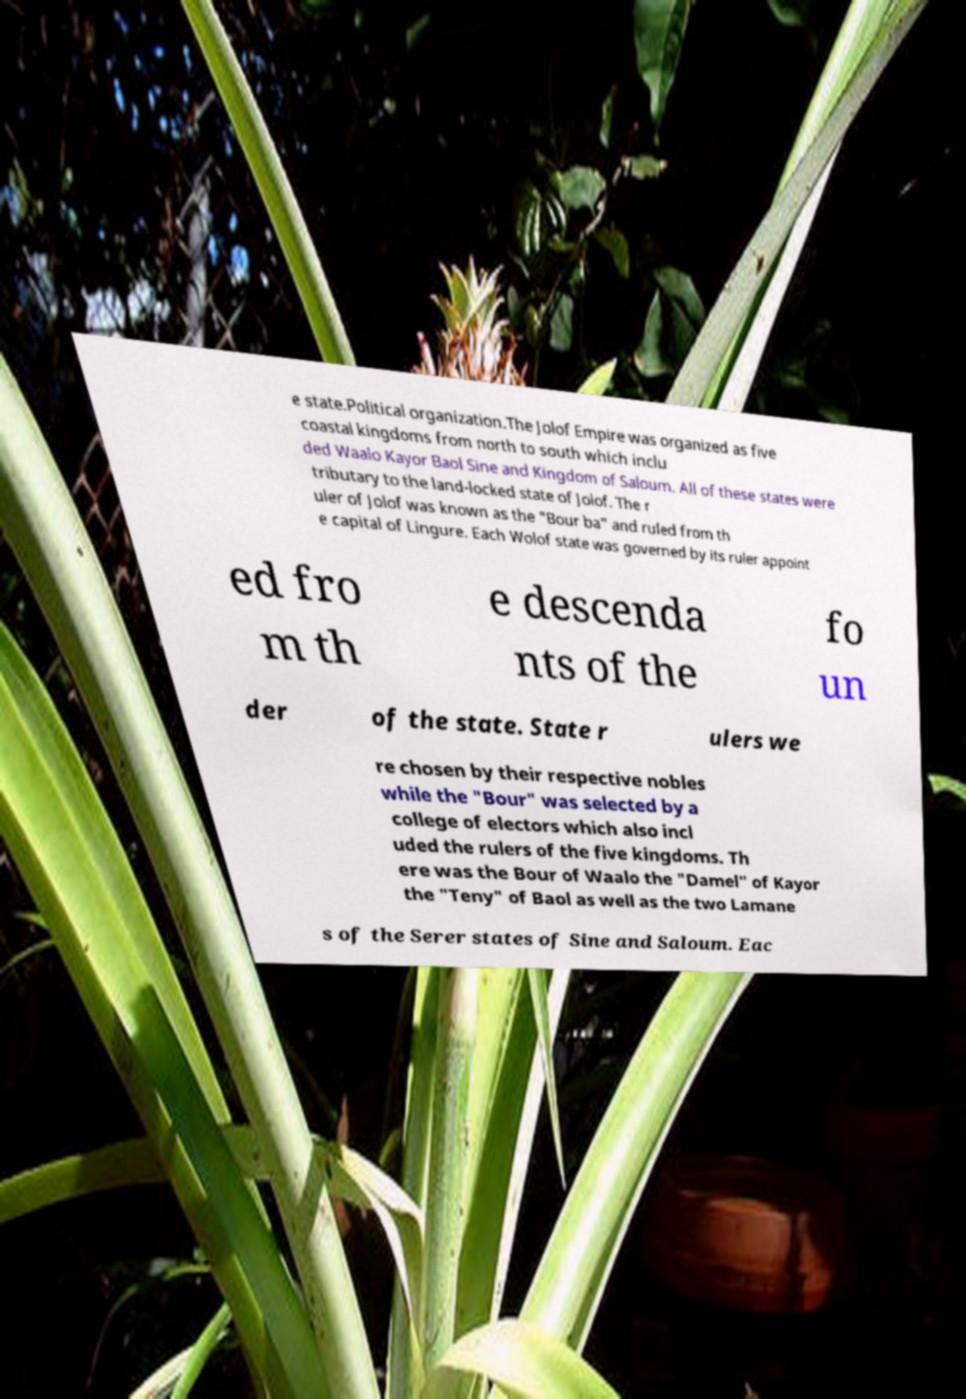Please read and relay the text visible in this image. What does it say? e state.Political organization.The Jolof Empire was organized as five coastal kingdoms from north to south which inclu ded Waalo Kayor Baol Sine and Kingdom of Saloum. All of these states were tributary to the land-locked state of Jolof. The r uler of Jolof was known as the "Bour ba" and ruled from th e capital of Lingure. Each Wolof state was governed by its ruler appoint ed fro m th e descenda nts of the fo un der of the state. State r ulers we re chosen by their respective nobles while the "Bour" was selected by a college of electors which also incl uded the rulers of the five kingdoms. Th ere was the Bour of Waalo the "Damel" of Kayor the "Teny" of Baol as well as the two Lamane s of the Serer states of Sine and Saloum. Eac 